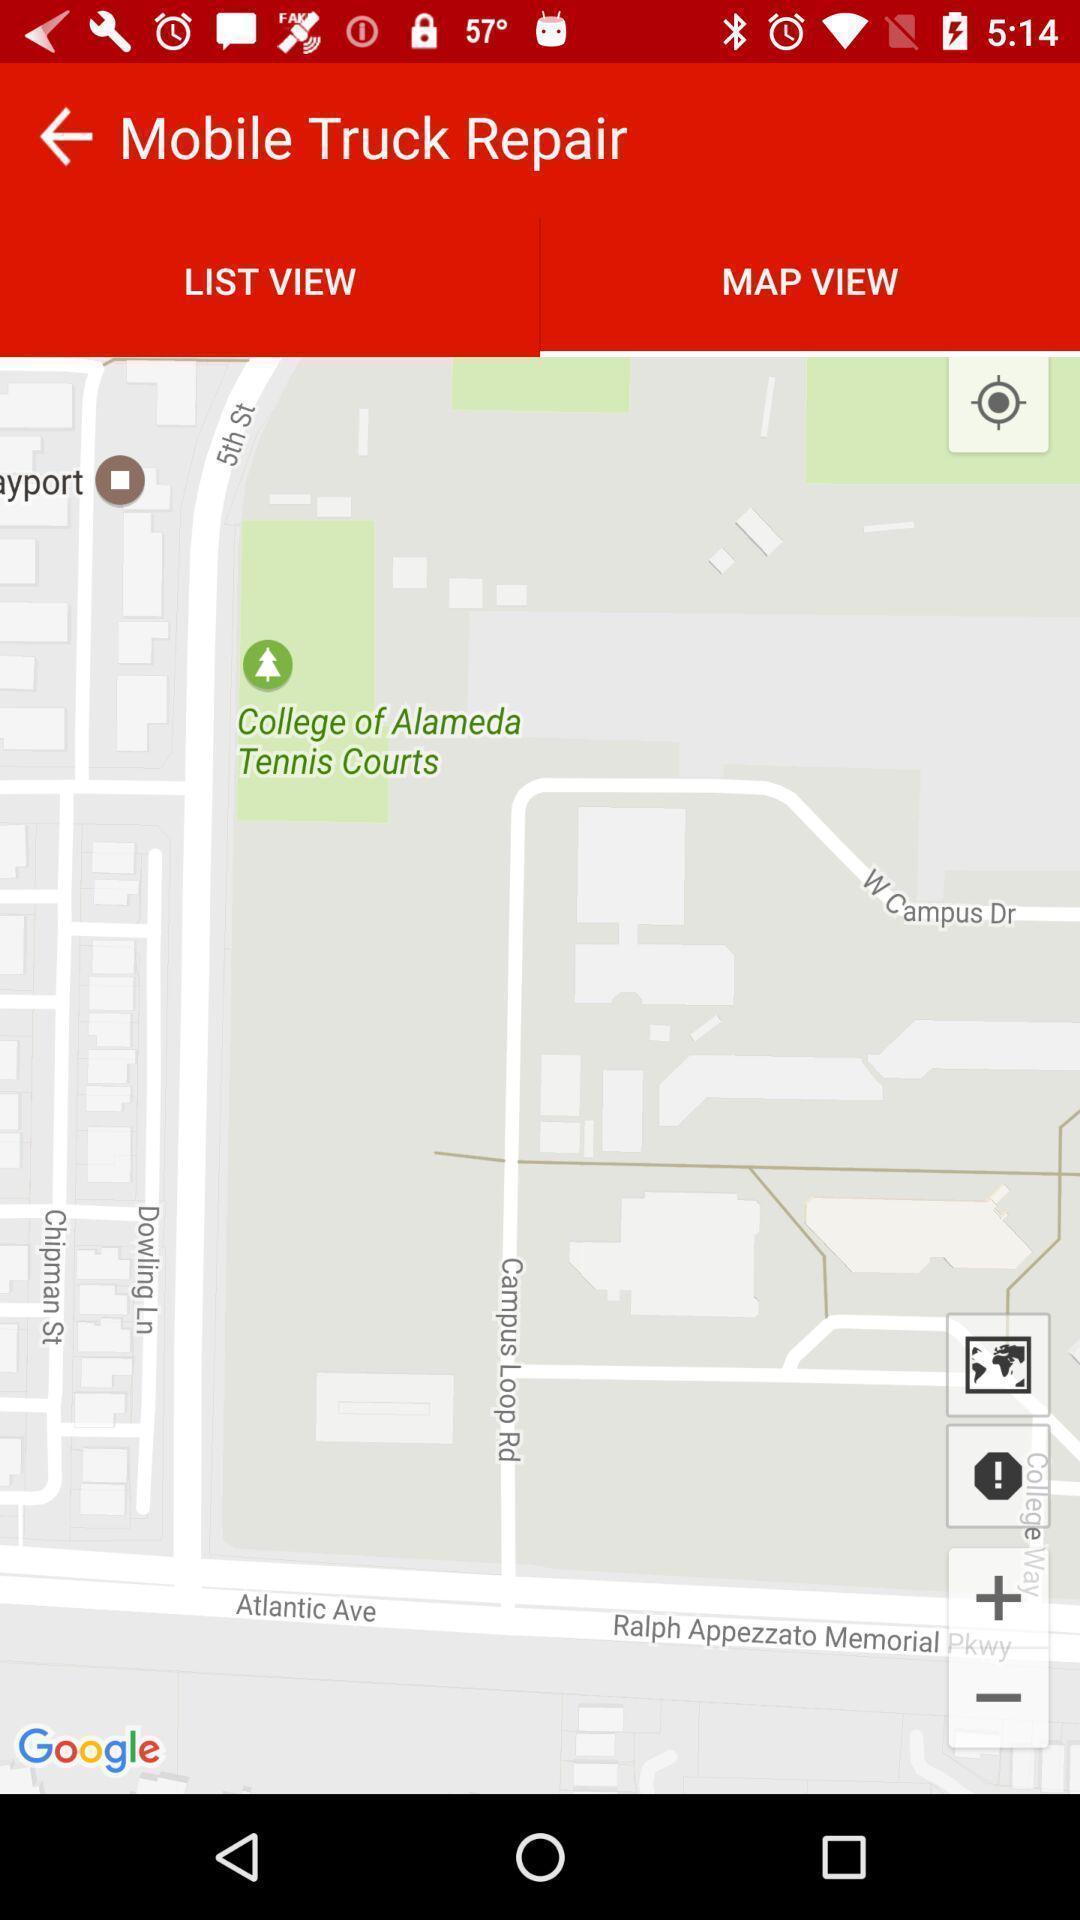Summarize the main components in this picture. Page displaying maps for the search and with few options. 